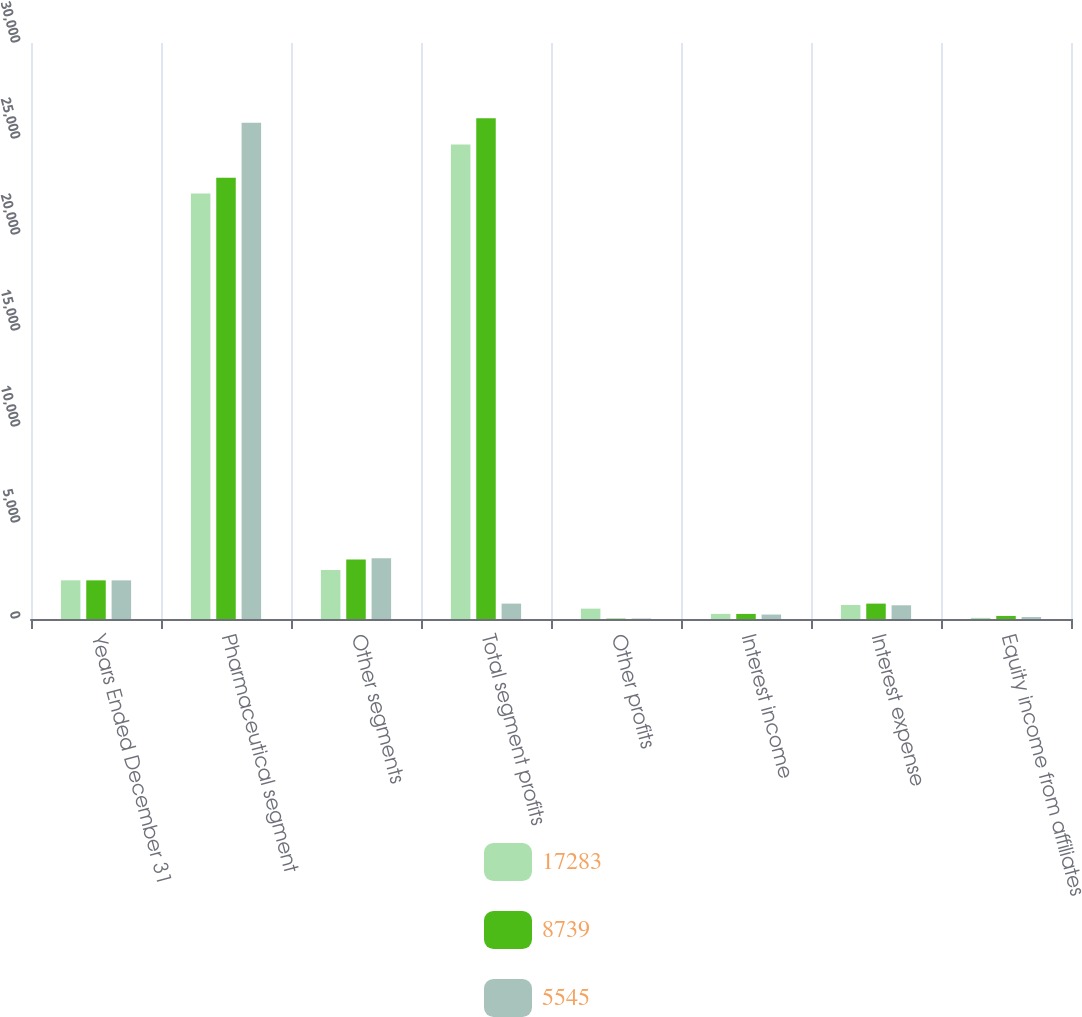<chart> <loc_0><loc_0><loc_500><loc_500><stacked_bar_chart><ecel><fcel>Years Ended December 31<fcel>Pharmaceutical segment<fcel>Other segments<fcel>Total segment profits<fcel>Other profits<fcel>Interest income<fcel>Interest expense<fcel>Equity income from affiliates<nl><fcel>17283<fcel>2014<fcel>22164<fcel>2546<fcel>24710<fcel>539<fcel>266<fcel>732<fcel>59<nl><fcel>8739<fcel>2013<fcel>22983<fcel>3094<fcel>26077<fcel>19<fcel>264<fcel>801<fcel>159<nl><fcel>5545<fcel>2012<fcel>25852<fcel>3163<fcel>801<fcel>26<fcel>232<fcel>714<fcel>102<nl></chart> 